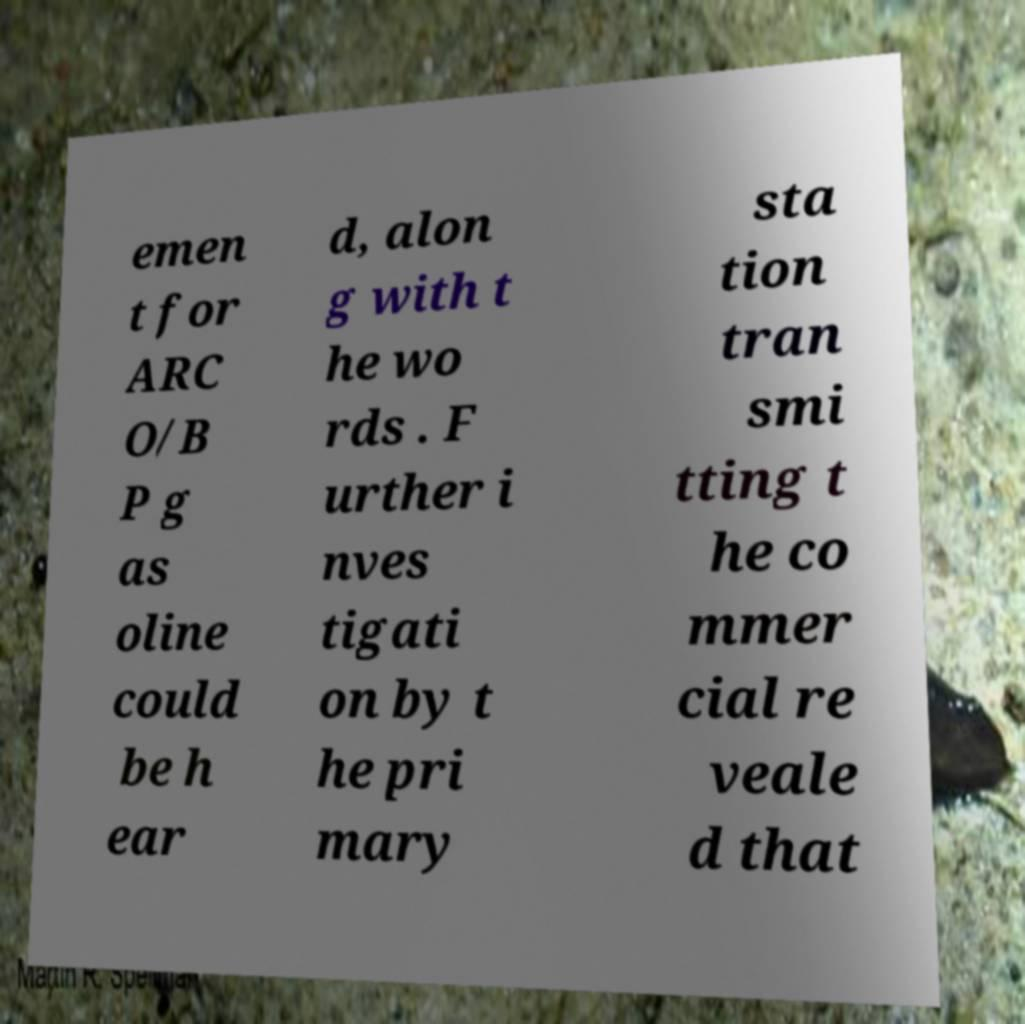There's text embedded in this image that I need extracted. Can you transcribe it verbatim? emen t for ARC O/B P g as oline could be h ear d, alon g with t he wo rds . F urther i nves tigati on by t he pri mary sta tion tran smi tting t he co mmer cial re veale d that 